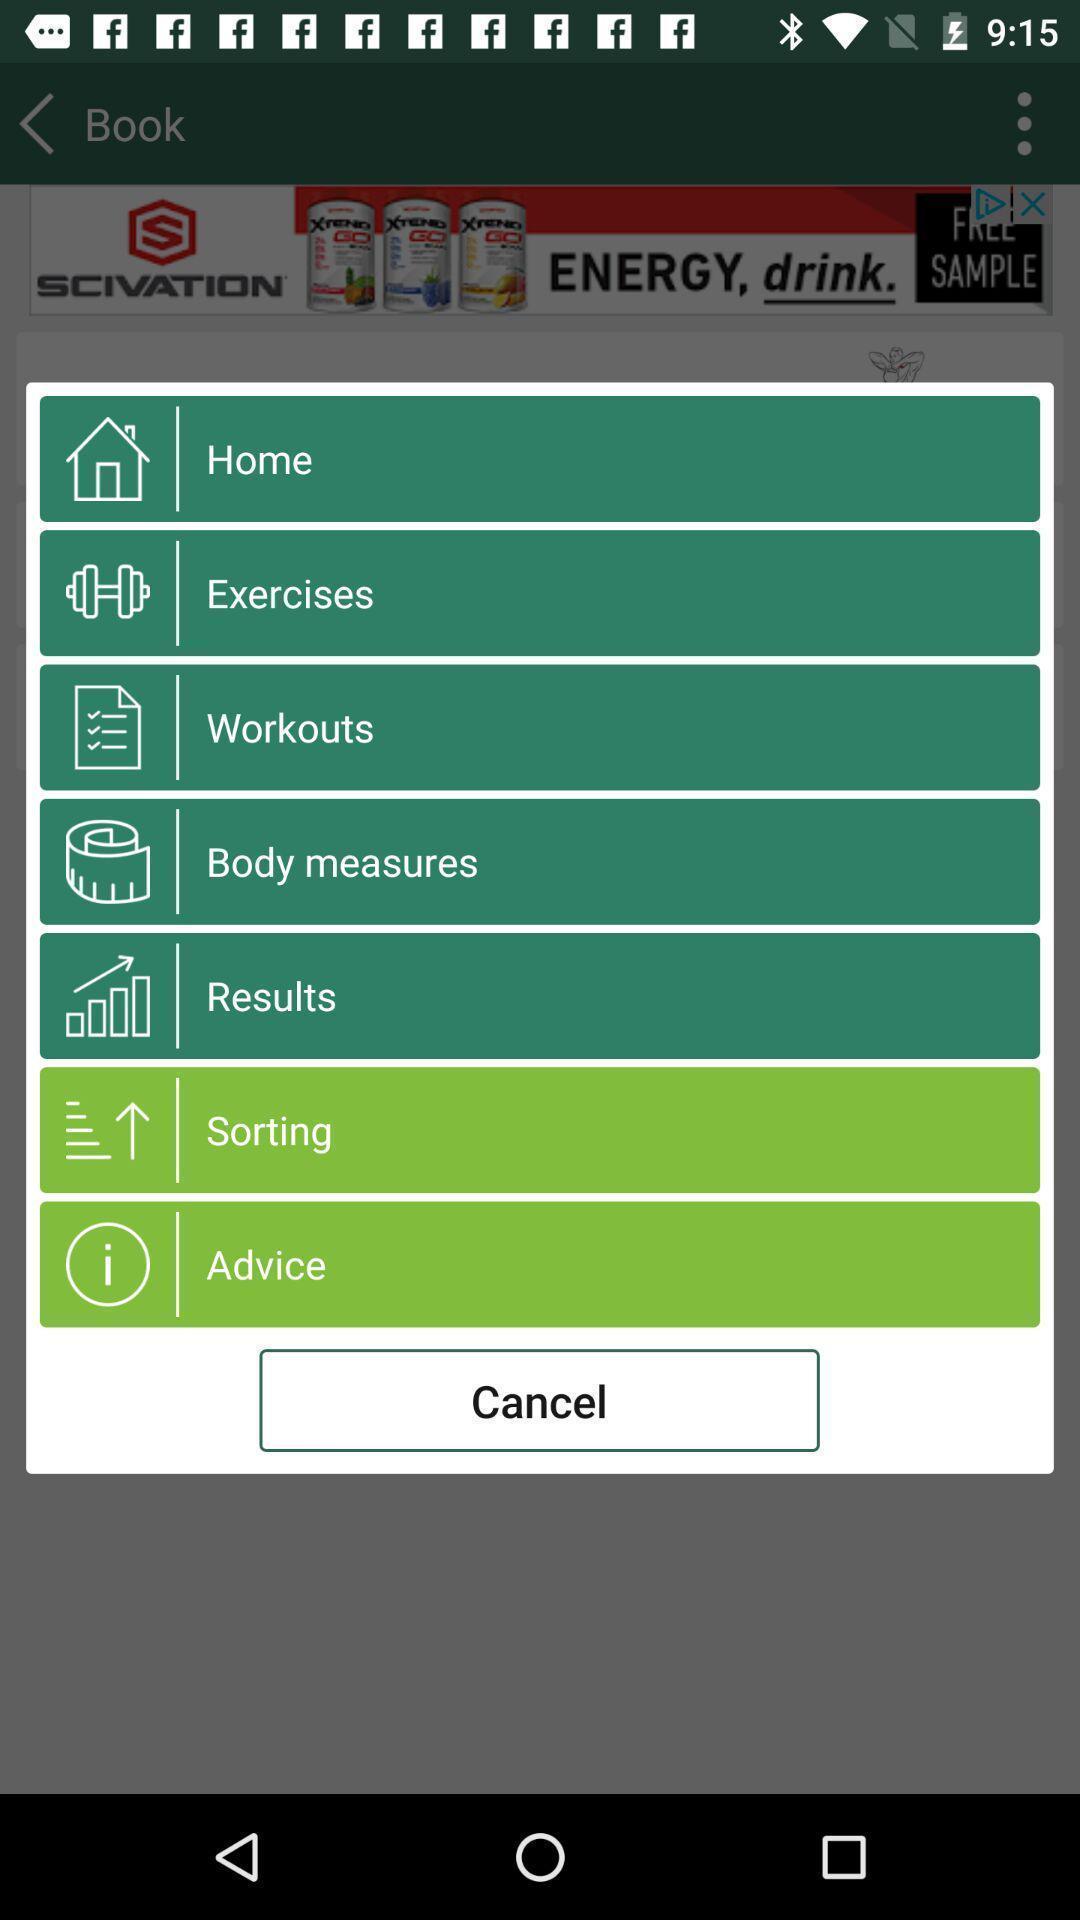Provide a textual representation of this image. Screen shows list of options in fitness application. 